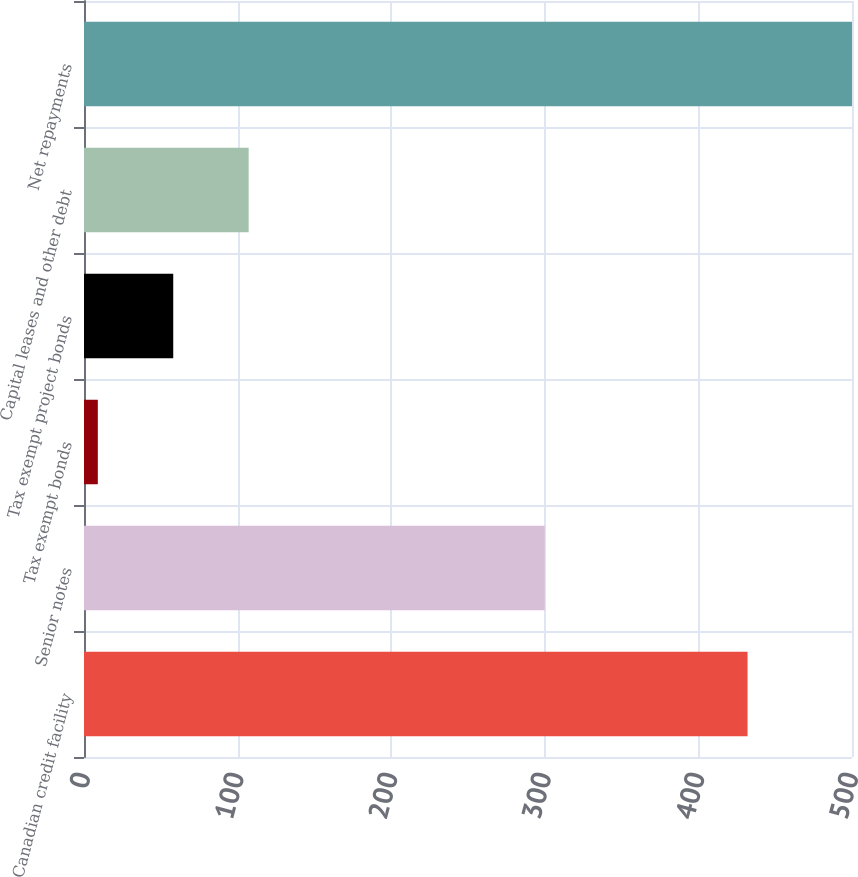Convert chart to OTSL. <chart><loc_0><loc_0><loc_500><loc_500><bar_chart><fcel>Canadian credit facility<fcel>Senior notes<fcel>Tax exempt bonds<fcel>Tax exempt project bonds<fcel>Capital leases and other debt<fcel>Net repayments<nl><fcel>432<fcel>300<fcel>9<fcel>58.1<fcel>107.2<fcel>500<nl></chart> 